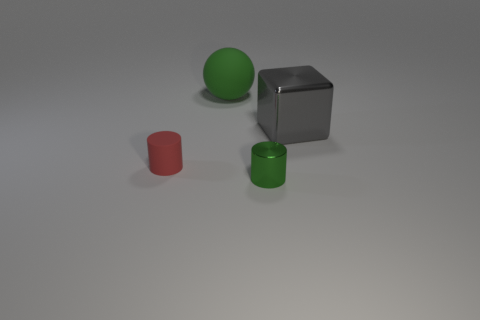Add 1 rubber cylinders. How many objects exist? 5 Subtract all spheres. How many objects are left? 3 Subtract all red cylinders. How many cylinders are left? 1 Add 1 big gray metallic blocks. How many big gray metallic blocks exist? 2 Subtract 1 gray blocks. How many objects are left? 3 Subtract all cyan balls. Subtract all brown blocks. How many balls are left? 1 Subtract all green spheres. Subtract all tiny cyan metallic cylinders. How many objects are left? 3 Add 2 green rubber things. How many green rubber things are left? 3 